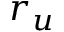Convert formula to latex. <formula><loc_0><loc_0><loc_500><loc_500>r _ { u }</formula> 